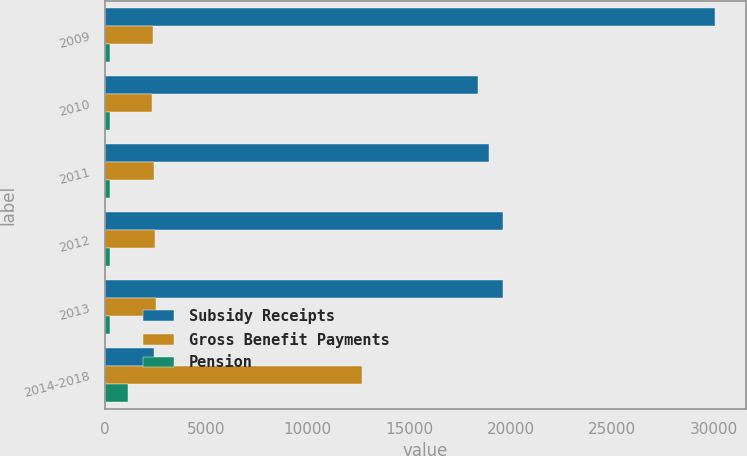Convert chart to OTSL. <chart><loc_0><loc_0><loc_500><loc_500><stacked_bar_chart><ecel><fcel>2009<fcel>2010<fcel>2011<fcel>2012<fcel>2013<fcel>2014-2018<nl><fcel>Subsidy Receipts<fcel>30077<fcel>18398<fcel>18916<fcel>19613<fcel>19608<fcel>2406<nl><fcel>Gross Benefit Payments<fcel>2382<fcel>2311<fcel>2406<fcel>2463<fcel>2525<fcel>12651<nl><fcel>Pension<fcel>262<fcel>267<fcel>268<fcel>267<fcel>261<fcel>1123<nl></chart> 